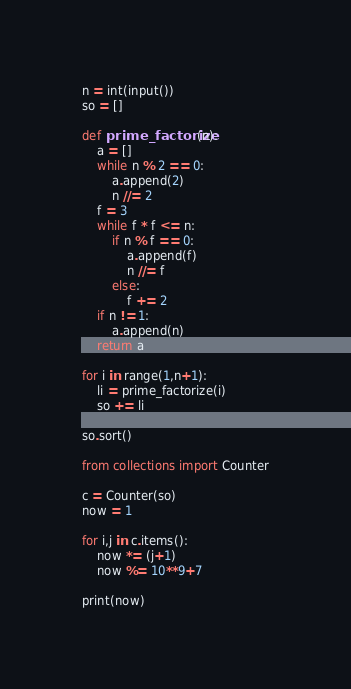<code> <loc_0><loc_0><loc_500><loc_500><_Python_>n = int(input())
so = []

def prime_factorize(n):
    a = []
    while n % 2 == 0:
        a.append(2)
        n //= 2
    f = 3
    while f * f <= n:
        if n % f == 0:
            a.append(f)
            n //= f
        else:
            f += 2
    if n != 1:
        a.append(n)
    return a

for i in range(1,n+1):
    li = prime_factorize(i)
    so += li

so.sort()

from collections import Counter

c = Counter(so)
now = 1

for i,j in c.items():
    now *= (j+1)
    now %= 10**9+7

print(now)</code> 